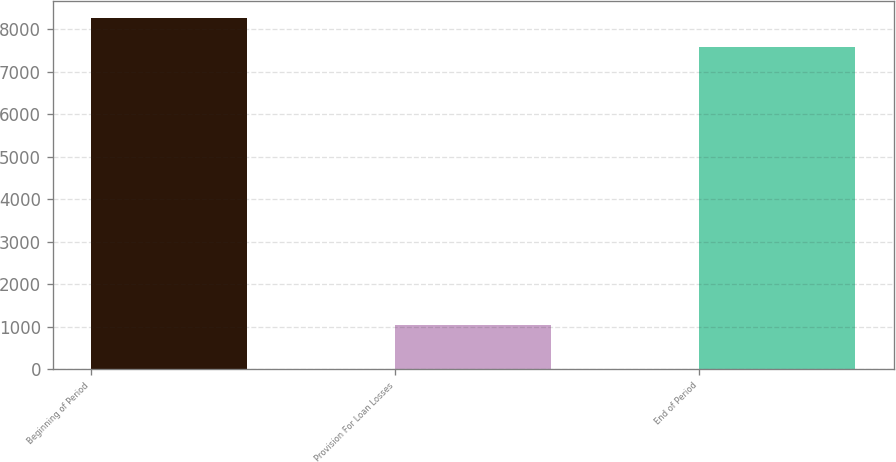Convert chart. <chart><loc_0><loc_0><loc_500><loc_500><bar_chart><fcel>Beginning of Period<fcel>Provision For Loan Losses<fcel>End of Period<nl><fcel>8253.5<fcel>1037<fcel>7593<nl></chart> 